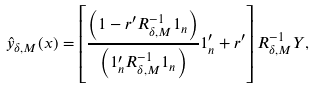<formula> <loc_0><loc_0><loc_500><loc_500>\hat { y } _ { \delta , M } ( x ) = \left [ \frac { \left ( 1 - r ^ { \prime } R ^ { - 1 } _ { \delta , M } 1 _ { n } \right ) } { \left ( 1 _ { n } ^ { \prime } R ^ { - 1 } _ { \delta , M } 1 _ { n } \right ) } 1 _ { n } ^ { \prime } + r ^ { \prime } \right ] R ^ { - 1 } _ { \delta , M } Y ,</formula> 